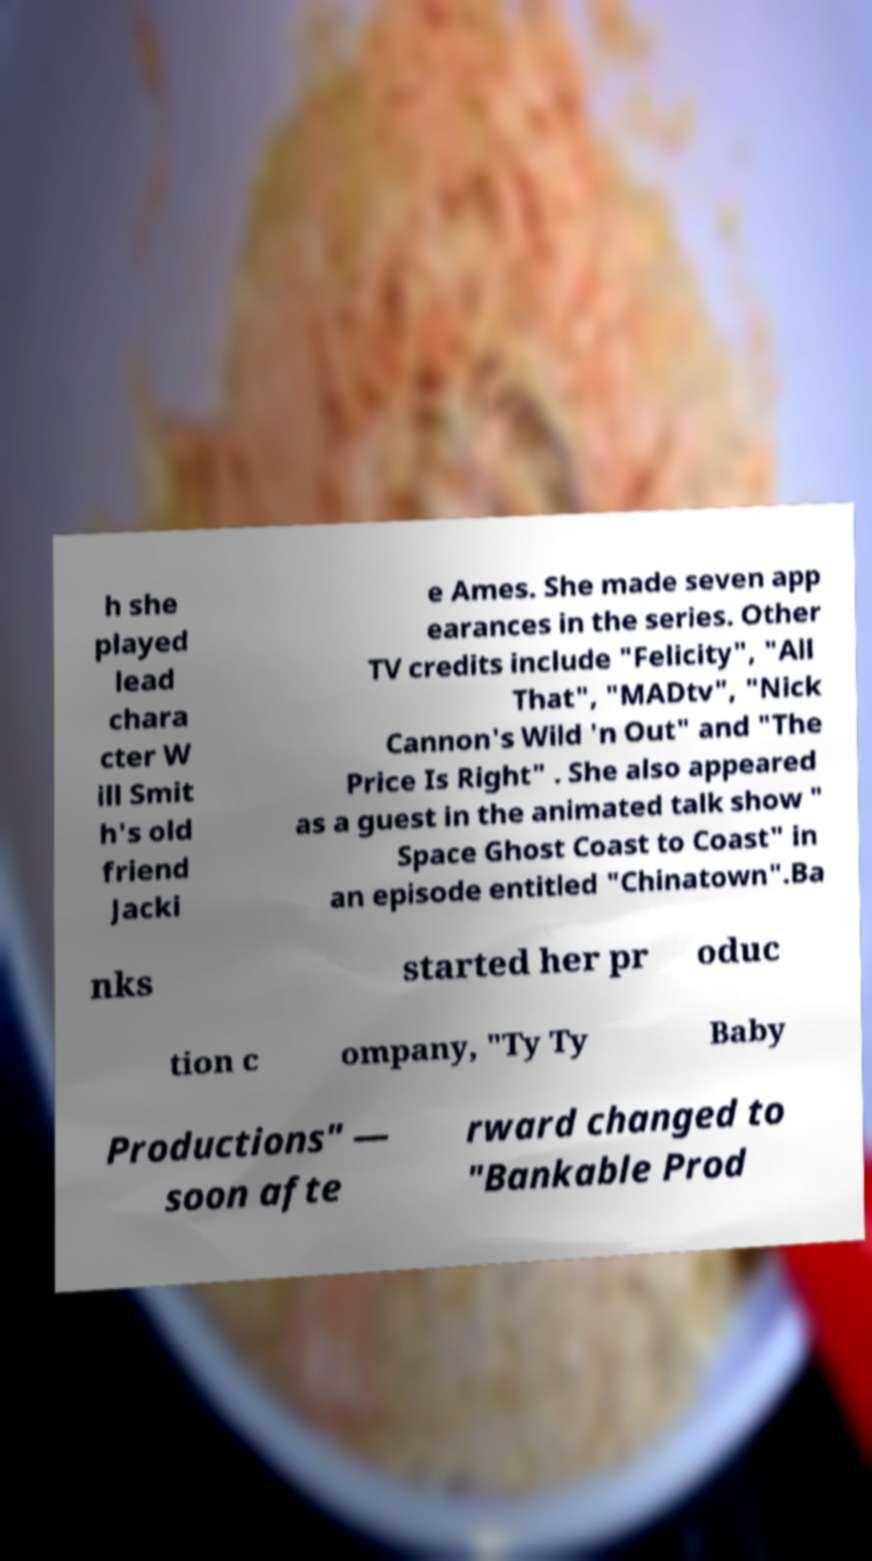For documentation purposes, I need the text within this image transcribed. Could you provide that? h she played lead chara cter W ill Smit h's old friend Jacki e Ames. She made seven app earances in the series. Other TV credits include "Felicity", "All That", "MADtv", "Nick Cannon's Wild 'n Out" and "The Price Is Right" . She also appeared as a guest in the animated talk show " Space Ghost Coast to Coast" in an episode entitled "Chinatown".Ba nks started her pr oduc tion c ompany, "Ty Ty Baby Productions" — soon afte rward changed to "Bankable Prod 